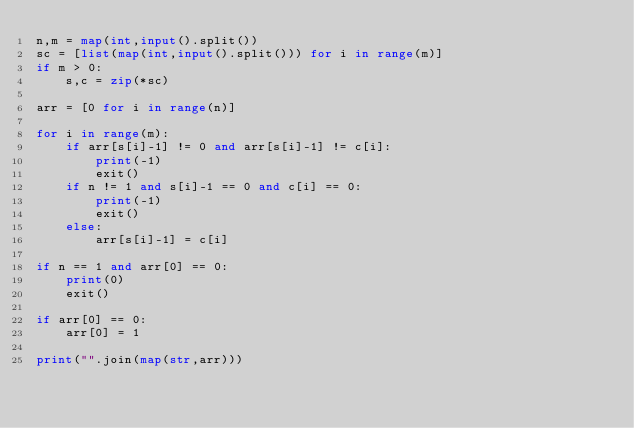Convert code to text. <code><loc_0><loc_0><loc_500><loc_500><_Python_>n,m = map(int,input().split())
sc = [list(map(int,input().split())) for i in range(m)]
if m > 0:
    s,c = zip(*sc)

arr = [0 for i in range(n)]

for i in range(m):
    if arr[s[i]-1] != 0 and arr[s[i]-1] != c[i]:
        print(-1)
        exit()
    if n != 1 and s[i]-1 == 0 and c[i] == 0:
        print(-1)
        exit()
    else:
        arr[s[i]-1] = c[i]

if n == 1 and arr[0] == 0:
    print(0)
    exit()

if arr[0] == 0:
    arr[0] = 1

print("".join(map(str,arr)))</code> 